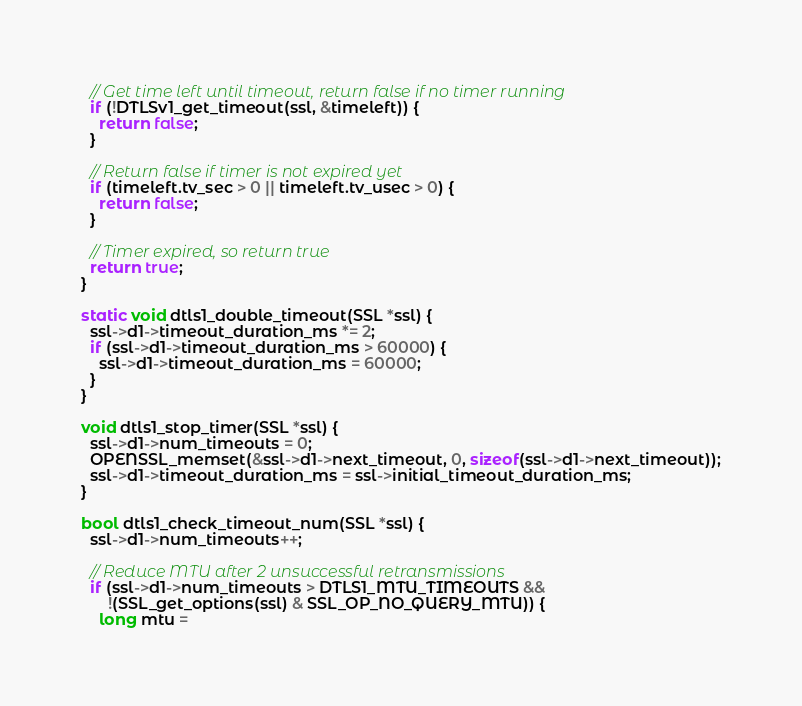<code> <loc_0><loc_0><loc_500><loc_500><_C++_>
  // Get time left until timeout, return false if no timer running
  if (!DTLSv1_get_timeout(ssl, &timeleft)) {
    return false;
  }

  // Return false if timer is not expired yet
  if (timeleft.tv_sec > 0 || timeleft.tv_usec > 0) {
    return false;
  }

  // Timer expired, so return true
  return true;
}

static void dtls1_double_timeout(SSL *ssl) {
  ssl->d1->timeout_duration_ms *= 2;
  if (ssl->d1->timeout_duration_ms > 60000) {
    ssl->d1->timeout_duration_ms = 60000;
  }
}

void dtls1_stop_timer(SSL *ssl) {
  ssl->d1->num_timeouts = 0;
  OPENSSL_memset(&ssl->d1->next_timeout, 0, sizeof(ssl->d1->next_timeout));
  ssl->d1->timeout_duration_ms = ssl->initial_timeout_duration_ms;
}

bool dtls1_check_timeout_num(SSL *ssl) {
  ssl->d1->num_timeouts++;

  // Reduce MTU after 2 unsuccessful retransmissions
  if (ssl->d1->num_timeouts > DTLS1_MTU_TIMEOUTS &&
      !(SSL_get_options(ssl) & SSL_OP_NO_QUERY_MTU)) {
    long mtu =</code> 